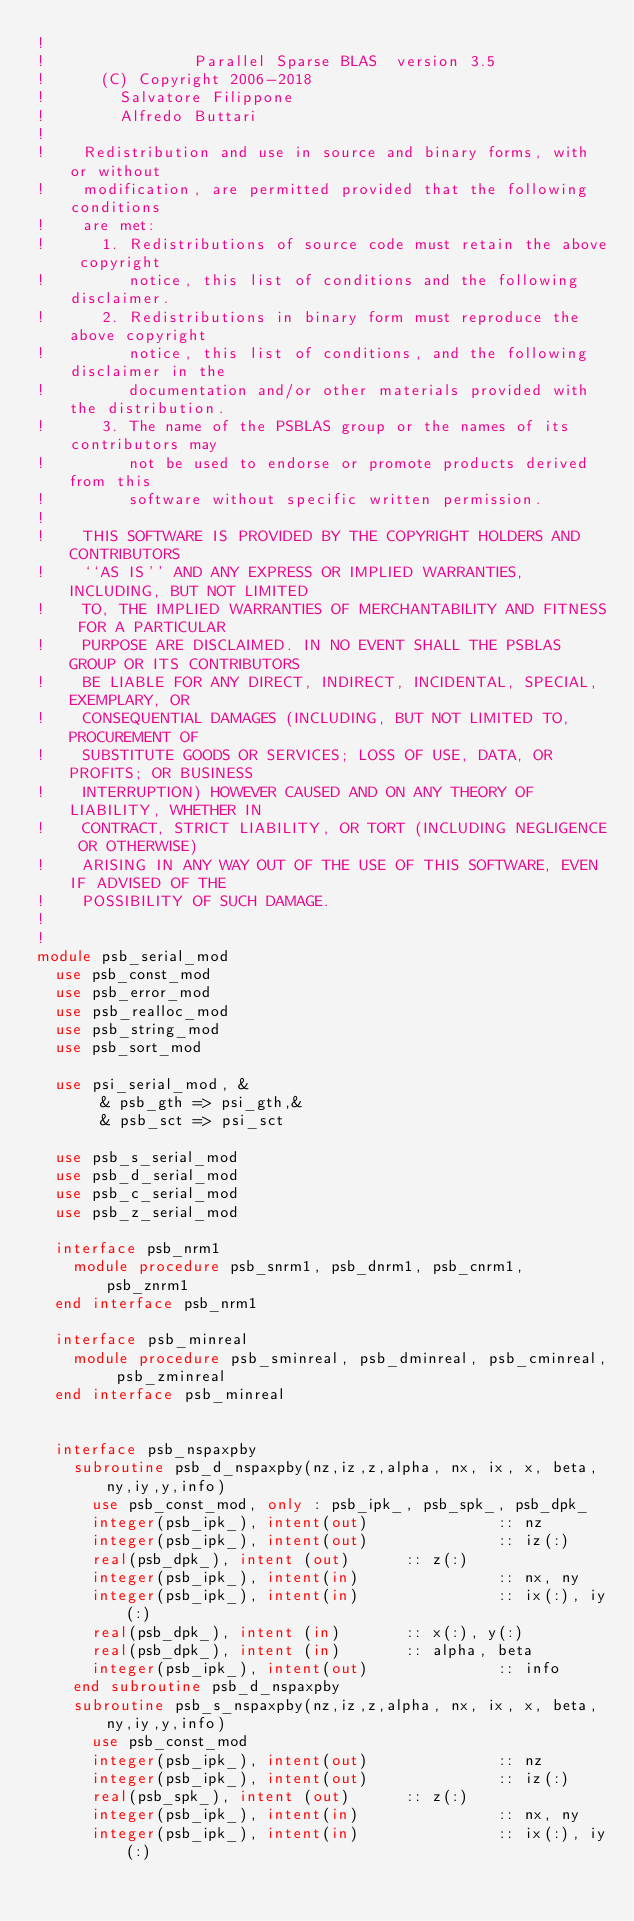<code> <loc_0><loc_0><loc_500><loc_500><_FORTRAN_>!
!                Parallel Sparse BLAS  version 3.5
!      (C) Copyright 2006-2018
!        Salvatore Filippone
!        Alfredo Buttari
!
!    Redistribution and use in source and binary forms, with or without
!    modification, are permitted provided that the following conditions
!    are met:
!      1. Redistributions of source code must retain the above copyright
!         notice, this list of conditions and the following disclaimer.
!      2. Redistributions in binary form must reproduce the above copyright
!         notice, this list of conditions, and the following disclaimer in the
!         documentation and/or other materials provided with the distribution.
!      3. The name of the PSBLAS group or the names of its contributors may
!         not be used to endorse or promote products derived from this
!         software without specific written permission.
!
!    THIS SOFTWARE IS PROVIDED BY THE COPYRIGHT HOLDERS AND CONTRIBUTORS
!    ``AS IS'' AND ANY EXPRESS OR IMPLIED WARRANTIES, INCLUDING, BUT NOT LIMITED
!    TO, THE IMPLIED WARRANTIES OF MERCHANTABILITY AND FITNESS FOR A PARTICULAR
!    PURPOSE ARE DISCLAIMED. IN NO EVENT SHALL THE PSBLAS GROUP OR ITS CONTRIBUTORS
!    BE LIABLE FOR ANY DIRECT, INDIRECT, INCIDENTAL, SPECIAL, EXEMPLARY, OR
!    CONSEQUENTIAL DAMAGES (INCLUDING, BUT NOT LIMITED TO, PROCUREMENT OF
!    SUBSTITUTE GOODS OR SERVICES; LOSS OF USE, DATA, OR PROFITS; OR BUSINESS
!    INTERRUPTION) HOWEVER CAUSED AND ON ANY THEORY OF LIABILITY, WHETHER IN
!    CONTRACT, STRICT LIABILITY, OR TORT (INCLUDING NEGLIGENCE OR OTHERWISE)
!    ARISING IN ANY WAY OUT OF THE USE OF THIS SOFTWARE, EVEN IF ADVISED OF THE
!    POSSIBILITY OF SUCH DAMAGE.
!
!
module psb_serial_mod
  use psb_const_mod
  use psb_error_mod
  use psb_realloc_mod
  use psb_string_mod
  use psb_sort_mod

  use psi_serial_mod, &
       & psb_gth => psi_gth,&
       & psb_sct => psi_sct

  use psb_s_serial_mod
  use psb_d_serial_mod
  use psb_c_serial_mod
  use psb_z_serial_mod

  interface psb_nrm1
    module procedure psb_snrm1, psb_dnrm1, psb_cnrm1, psb_znrm1
  end interface psb_nrm1

  interface psb_minreal
    module procedure psb_sminreal, psb_dminreal, psb_cminreal, psb_zminreal
  end interface psb_minreal


  interface psb_nspaxpby
    subroutine psb_d_nspaxpby(nz,iz,z,alpha, nx, ix, x, beta, ny,iy,y,info)
      use psb_const_mod, only : psb_ipk_, psb_spk_, psb_dpk_
      integer(psb_ipk_), intent(out)              :: nz
      integer(psb_ipk_), intent(out)              :: iz(:)
      real(psb_dpk_), intent (out)      :: z(:)
      integer(psb_ipk_), intent(in)               :: nx, ny
      integer(psb_ipk_), intent(in)               :: ix(:), iy(:)
      real(psb_dpk_), intent (in)       :: x(:), y(:)
      real(psb_dpk_), intent (in)       :: alpha, beta
      integer(psb_ipk_), intent(out)              :: info
    end subroutine psb_d_nspaxpby
    subroutine psb_s_nspaxpby(nz,iz,z,alpha, nx, ix, x, beta, ny,iy,y,info)
      use psb_const_mod
      integer(psb_ipk_), intent(out)              :: nz
      integer(psb_ipk_), intent(out)              :: iz(:)
      real(psb_spk_), intent (out)      :: z(:)
      integer(psb_ipk_), intent(in)               :: nx, ny
      integer(psb_ipk_), intent(in)               :: ix(:), iy(:)</code> 